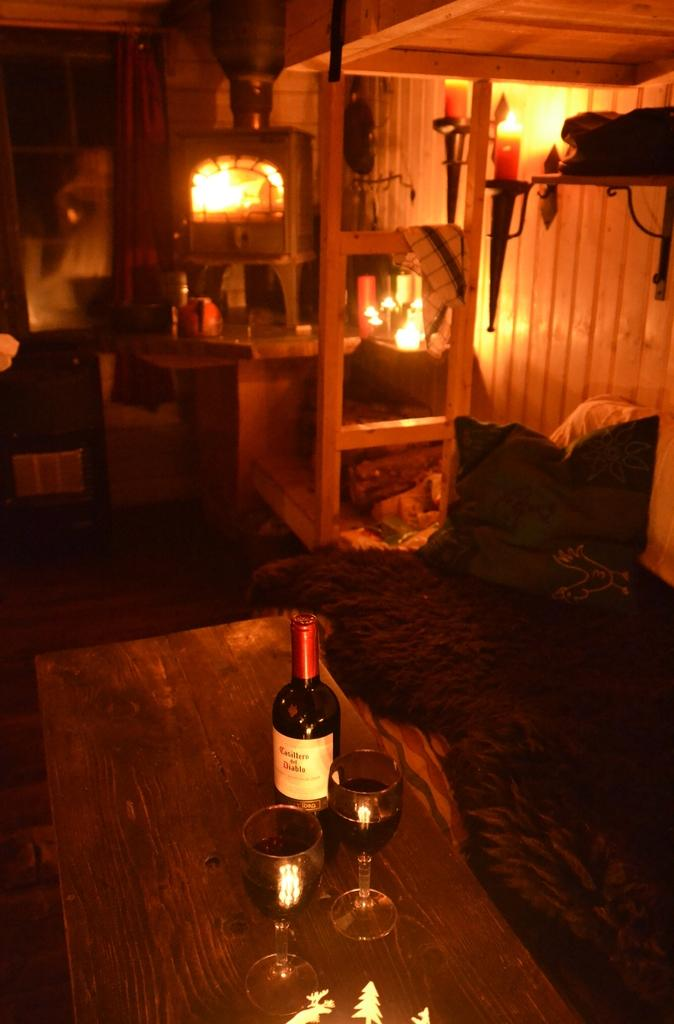What piece of furniture is present in the image? There is a table in the image. What is on the table? There is a wine bottle and two wine glasses on the table. Where is the bed located in the image? The bed is on the right side of the image. What is on the bed? There is a pillow on the bed. What is a source of heat in the image? There is a fireplace in the image. How many candles are lighted in the image? Two candles are lighted in the image. What type of digestion is taking place in the image? There is no digestion taking place in the image; it is a still scene with a table, wine bottle, wine glasses, bed, pillow, fireplace, and candles. What type of coach is present in the image? There is no coach present in the image. 